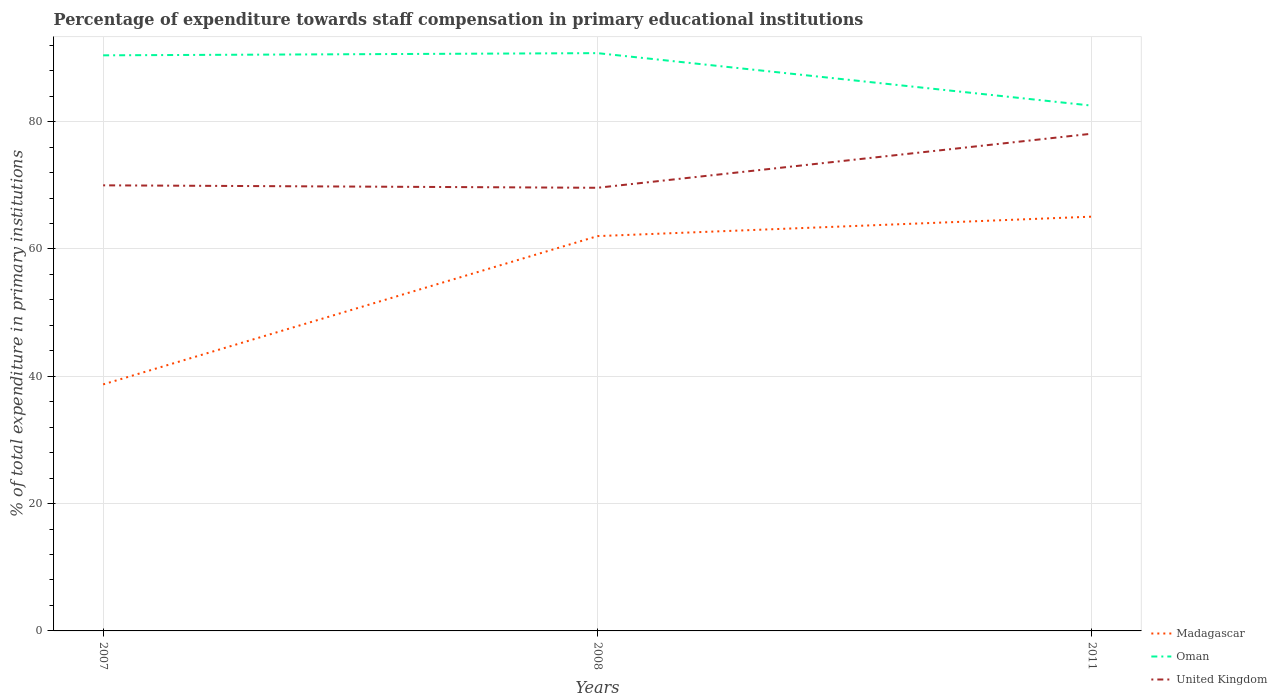Is the number of lines equal to the number of legend labels?
Give a very brief answer. Yes. Across all years, what is the maximum percentage of expenditure towards staff compensation in United Kingdom?
Keep it short and to the point. 69.61. What is the total percentage of expenditure towards staff compensation in Madagascar in the graph?
Make the answer very short. -3.06. What is the difference between the highest and the second highest percentage of expenditure towards staff compensation in Oman?
Provide a succinct answer. 8.25. Is the percentage of expenditure towards staff compensation in Madagascar strictly greater than the percentage of expenditure towards staff compensation in United Kingdom over the years?
Your answer should be very brief. Yes. How many years are there in the graph?
Provide a succinct answer. 3. What is the difference between two consecutive major ticks on the Y-axis?
Your response must be concise. 20. Does the graph contain grids?
Offer a terse response. Yes. How many legend labels are there?
Offer a very short reply. 3. How are the legend labels stacked?
Your response must be concise. Vertical. What is the title of the graph?
Ensure brevity in your answer.  Percentage of expenditure towards staff compensation in primary educational institutions. Does "Saudi Arabia" appear as one of the legend labels in the graph?
Make the answer very short. No. What is the label or title of the X-axis?
Provide a succinct answer. Years. What is the label or title of the Y-axis?
Your response must be concise. % of total expenditure in primary institutions. What is the % of total expenditure in primary institutions of Madagascar in 2007?
Provide a succinct answer. 38.72. What is the % of total expenditure in primary institutions of Oman in 2007?
Keep it short and to the point. 90.41. What is the % of total expenditure in primary institutions in United Kingdom in 2007?
Ensure brevity in your answer.  69.99. What is the % of total expenditure in primary institutions of Madagascar in 2008?
Your answer should be compact. 62.02. What is the % of total expenditure in primary institutions in Oman in 2008?
Ensure brevity in your answer.  90.76. What is the % of total expenditure in primary institutions of United Kingdom in 2008?
Your answer should be very brief. 69.61. What is the % of total expenditure in primary institutions of Madagascar in 2011?
Give a very brief answer. 65.07. What is the % of total expenditure in primary institutions in Oman in 2011?
Offer a terse response. 82.51. What is the % of total expenditure in primary institutions in United Kingdom in 2011?
Offer a terse response. 78.1. Across all years, what is the maximum % of total expenditure in primary institutions in Madagascar?
Keep it short and to the point. 65.07. Across all years, what is the maximum % of total expenditure in primary institutions in Oman?
Make the answer very short. 90.76. Across all years, what is the maximum % of total expenditure in primary institutions of United Kingdom?
Ensure brevity in your answer.  78.1. Across all years, what is the minimum % of total expenditure in primary institutions of Madagascar?
Keep it short and to the point. 38.72. Across all years, what is the minimum % of total expenditure in primary institutions of Oman?
Your answer should be very brief. 82.51. Across all years, what is the minimum % of total expenditure in primary institutions in United Kingdom?
Your response must be concise. 69.61. What is the total % of total expenditure in primary institutions of Madagascar in the graph?
Keep it short and to the point. 165.81. What is the total % of total expenditure in primary institutions of Oman in the graph?
Offer a very short reply. 263.68. What is the total % of total expenditure in primary institutions of United Kingdom in the graph?
Make the answer very short. 217.7. What is the difference between the % of total expenditure in primary institutions in Madagascar in 2007 and that in 2008?
Make the answer very short. -23.29. What is the difference between the % of total expenditure in primary institutions of Oman in 2007 and that in 2008?
Ensure brevity in your answer.  -0.34. What is the difference between the % of total expenditure in primary institutions of United Kingdom in 2007 and that in 2008?
Ensure brevity in your answer.  0.38. What is the difference between the % of total expenditure in primary institutions of Madagascar in 2007 and that in 2011?
Provide a succinct answer. -26.35. What is the difference between the % of total expenditure in primary institutions in Oman in 2007 and that in 2011?
Your answer should be very brief. 7.9. What is the difference between the % of total expenditure in primary institutions in United Kingdom in 2007 and that in 2011?
Offer a terse response. -8.11. What is the difference between the % of total expenditure in primary institutions in Madagascar in 2008 and that in 2011?
Your answer should be very brief. -3.06. What is the difference between the % of total expenditure in primary institutions of Oman in 2008 and that in 2011?
Ensure brevity in your answer.  8.25. What is the difference between the % of total expenditure in primary institutions in United Kingdom in 2008 and that in 2011?
Make the answer very short. -8.49. What is the difference between the % of total expenditure in primary institutions of Madagascar in 2007 and the % of total expenditure in primary institutions of Oman in 2008?
Your answer should be compact. -52.03. What is the difference between the % of total expenditure in primary institutions in Madagascar in 2007 and the % of total expenditure in primary institutions in United Kingdom in 2008?
Your response must be concise. -30.89. What is the difference between the % of total expenditure in primary institutions in Oman in 2007 and the % of total expenditure in primary institutions in United Kingdom in 2008?
Ensure brevity in your answer.  20.8. What is the difference between the % of total expenditure in primary institutions in Madagascar in 2007 and the % of total expenditure in primary institutions in Oman in 2011?
Give a very brief answer. -43.79. What is the difference between the % of total expenditure in primary institutions in Madagascar in 2007 and the % of total expenditure in primary institutions in United Kingdom in 2011?
Offer a terse response. -39.38. What is the difference between the % of total expenditure in primary institutions of Oman in 2007 and the % of total expenditure in primary institutions of United Kingdom in 2011?
Your response must be concise. 12.31. What is the difference between the % of total expenditure in primary institutions in Madagascar in 2008 and the % of total expenditure in primary institutions in Oman in 2011?
Keep it short and to the point. -20.49. What is the difference between the % of total expenditure in primary institutions of Madagascar in 2008 and the % of total expenditure in primary institutions of United Kingdom in 2011?
Ensure brevity in your answer.  -16.09. What is the difference between the % of total expenditure in primary institutions in Oman in 2008 and the % of total expenditure in primary institutions in United Kingdom in 2011?
Make the answer very short. 12.66. What is the average % of total expenditure in primary institutions in Madagascar per year?
Make the answer very short. 55.27. What is the average % of total expenditure in primary institutions in Oman per year?
Provide a short and direct response. 87.89. What is the average % of total expenditure in primary institutions in United Kingdom per year?
Give a very brief answer. 72.57. In the year 2007, what is the difference between the % of total expenditure in primary institutions of Madagascar and % of total expenditure in primary institutions of Oman?
Your answer should be very brief. -51.69. In the year 2007, what is the difference between the % of total expenditure in primary institutions in Madagascar and % of total expenditure in primary institutions in United Kingdom?
Make the answer very short. -31.27. In the year 2007, what is the difference between the % of total expenditure in primary institutions of Oman and % of total expenditure in primary institutions of United Kingdom?
Your answer should be very brief. 20.42. In the year 2008, what is the difference between the % of total expenditure in primary institutions in Madagascar and % of total expenditure in primary institutions in Oman?
Give a very brief answer. -28.74. In the year 2008, what is the difference between the % of total expenditure in primary institutions in Madagascar and % of total expenditure in primary institutions in United Kingdom?
Your answer should be very brief. -7.59. In the year 2008, what is the difference between the % of total expenditure in primary institutions of Oman and % of total expenditure in primary institutions of United Kingdom?
Provide a short and direct response. 21.15. In the year 2011, what is the difference between the % of total expenditure in primary institutions of Madagascar and % of total expenditure in primary institutions of Oman?
Keep it short and to the point. -17.44. In the year 2011, what is the difference between the % of total expenditure in primary institutions in Madagascar and % of total expenditure in primary institutions in United Kingdom?
Your response must be concise. -13.03. In the year 2011, what is the difference between the % of total expenditure in primary institutions in Oman and % of total expenditure in primary institutions in United Kingdom?
Your response must be concise. 4.41. What is the ratio of the % of total expenditure in primary institutions in Madagascar in 2007 to that in 2008?
Keep it short and to the point. 0.62. What is the ratio of the % of total expenditure in primary institutions of Oman in 2007 to that in 2008?
Your answer should be very brief. 1. What is the ratio of the % of total expenditure in primary institutions of Madagascar in 2007 to that in 2011?
Offer a terse response. 0.6. What is the ratio of the % of total expenditure in primary institutions of Oman in 2007 to that in 2011?
Your answer should be compact. 1.1. What is the ratio of the % of total expenditure in primary institutions in United Kingdom in 2007 to that in 2011?
Your answer should be very brief. 0.9. What is the ratio of the % of total expenditure in primary institutions in Madagascar in 2008 to that in 2011?
Offer a terse response. 0.95. What is the ratio of the % of total expenditure in primary institutions of Oman in 2008 to that in 2011?
Offer a terse response. 1.1. What is the ratio of the % of total expenditure in primary institutions of United Kingdom in 2008 to that in 2011?
Offer a terse response. 0.89. What is the difference between the highest and the second highest % of total expenditure in primary institutions in Madagascar?
Give a very brief answer. 3.06. What is the difference between the highest and the second highest % of total expenditure in primary institutions in Oman?
Give a very brief answer. 0.34. What is the difference between the highest and the second highest % of total expenditure in primary institutions of United Kingdom?
Provide a succinct answer. 8.11. What is the difference between the highest and the lowest % of total expenditure in primary institutions in Madagascar?
Offer a very short reply. 26.35. What is the difference between the highest and the lowest % of total expenditure in primary institutions in Oman?
Provide a succinct answer. 8.25. What is the difference between the highest and the lowest % of total expenditure in primary institutions in United Kingdom?
Ensure brevity in your answer.  8.49. 